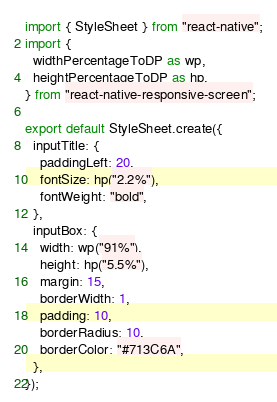<code> <loc_0><loc_0><loc_500><loc_500><_JavaScript_>import { StyleSheet } from "react-native";
import {
  widthPercentageToDP as wp,
  heightPercentageToDP as hp,
} from "react-native-responsive-screen";

export default StyleSheet.create({
  inputTitle: {
    paddingLeft: 20,
    fontSize: hp("2.2%"),
    fontWeight: "bold",
  },
  inputBox: {
    width: wp("91%"),
    height: hp("5.5%"),
    margin: 15,
    borderWidth: 1,
    padding: 10,
    borderRadius: 10,
    borderColor: "#713C6A",
  },
});
</code> 